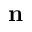<formula> <loc_0><loc_0><loc_500><loc_500>n</formula> 